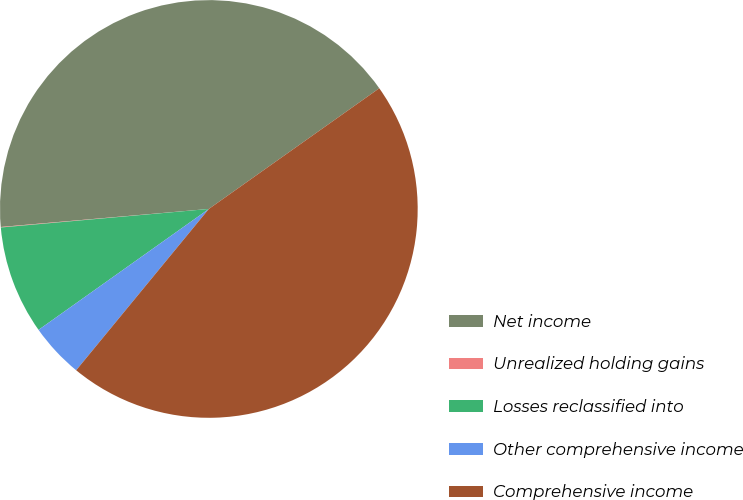Convert chart to OTSL. <chart><loc_0><loc_0><loc_500><loc_500><pie_chart><fcel>Net income<fcel>Unrealized holding gains<fcel>Losses reclassified into<fcel>Other comprehensive income<fcel>Comprehensive income<nl><fcel>41.57%<fcel>0.04%<fcel>8.41%<fcel>4.22%<fcel>45.76%<nl></chart> 